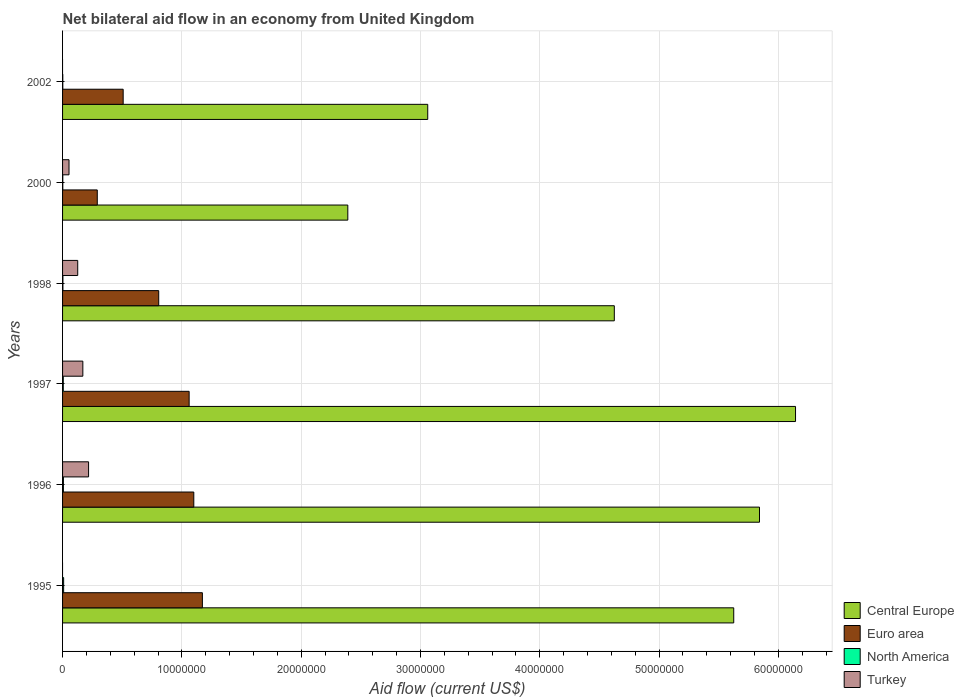How many groups of bars are there?
Your answer should be compact. 6. Are the number of bars per tick equal to the number of legend labels?
Offer a very short reply. No. Are the number of bars on each tick of the Y-axis equal?
Make the answer very short. No. How many bars are there on the 3rd tick from the top?
Offer a very short reply. 4. What is the label of the 1st group of bars from the top?
Offer a very short reply. 2002. What is the net bilateral aid flow in Euro area in 2002?
Give a very brief answer. 5.08e+06. Across all years, what is the minimum net bilateral aid flow in Euro area?
Provide a short and direct response. 2.91e+06. In which year was the net bilateral aid flow in Central Europe maximum?
Offer a terse response. 1997. What is the total net bilateral aid flow in North America in the graph?
Your answer should be compact. 2.90e+05. What is the difference between the net bilateral aid flow in Turkey in 1998 and that in 2000?
Your answer should be very brief. 7.30e+05. What is the difference between the net bilateral aid flow in Euro area in 2000 and the net bilateral aid flow in North America in 1995?
Give a very brief answer. 2.82e+06. What is the average net bilateral aid flow in North America per year?
Ensure brevity in your answer.  4.83e+04. In the year 1996, what is the difference between the net bilateral aid flow in Euro area and net bilateral aid flow in Turkey?
Your response must be concise. 8.82e+06. What is the ratio of the net bilateral aid flow in North America in 1995 to that in 1997?
Offer a terse response. 1.5. What is the difference between the highest and the second highest net bilateral aid flow in Central Europe?
Make the answer very short. 3.02e+06. What is the difference between the highest and the lowest net bilateral aid flow in Euro area?
Provide a short and direct response. 8.81e+06. Is the sum of the net bilateral aid flow in North America in 1997 and 2000 greater than the maximum net bilateral aid flow in Turkey across all years?
Provide a short and direct response. No. Is it the case that in every year, the sum of the net bilateral aid flow in Euro area and net bilateral aid flow in Central Europe is greater than the net bilateral aid flow in Turkey?
Offer a terse response. Yes. Where does the legend appear in the graph?
Provide a succinct answer. Bottom right. How many legend labels are there?
Your answer should be compact. 4. What is the title of the graph?
Provide a short and direct response. Net bilateral aid flow in an economy from United Kingdom. Does "St. Martin (French part)" appear as one of the legend labels in the graph?
Keep it short and to the point. No. What is the label or title of the X-axis?
Provide a short and direct response. Aid flow (current US$). What is the Aid flow (current US$) in Central Europe in 1995?
Your answer should be very brief. 5.63e+07. What is the Aid flow (current US$) in Euro area in 1995?
Make the answer very short. 1.17e+07. What is the Aid flow (current US$) in North America in 1995?
Give a very brief answer. 9.00e+04. What is the Aid flow (current US$) of Central Europe in 1996?
Offer a terse response. 5.84e+07. What is the Aid flow (current US$) in Euro area in 1996?
Offer a terse response. 1.10e+07. What is the Aid flow (current US$) in Turkey in 1996?
Provide a succinct answer. 2.18e+06. What is the Aid flow (current US$) in Central Europe in 1997?
Provide a short and direct response. 6.14e+07. What is the Aid flow (current US$) of Euro area in 1997?
Your response must be concise. 1.06e+07. What is the Aid flow (current US$) in North America in 1997?
Provide a succinct answer. 6.00e+04. What is the Aid flow (current US$) of Turkey in 1997?
Offer a very short reply. 1.70e+06. What is the Aid flow (current US$) in Central Europe in 1998?
Provide a succinct answer. 4.62e+07. What is the Aid flow (current US$) of Euro area in 1998?
Your answer should be very brief. 8.06e+06. What is the Aid flow (current US$) in North America in 1998?
Keep it short and to the point. 3.00e+04. What is the Aid flow (current US$) in Turkey in 1998?
Make the answer very short. 1.27e+06. What is the Aid flow (current US$) in Central Europe in 2000?
Make the answer very short. 2.39e+07. What is the Aid flow (current US$) in Euro area in 2000?
Offer a very short reply. 2.91e+06. What is the Aid flow (current US$) in Turkey in 2000?
Ensure brevity in your answer.  5.40e+05. What is the Aid flow (current US$) of Central Europe in 2002?
Your answer should be very brief. 3.06e+07. What is the Aid flow (current US$) of Euro area in 2002?
Your response must be concise. 5.08e+06. What is the Aid flow (current US$) in Turkey in 2002?
Your answer should be very brief. 0. Across all years, what is the maximum Aid flow (current US$) in Central Europe?
Give a very brief answer. 6.14e+07. Across all years, what is the maximum Aid flow (current US$) in Euro area?
Offer a terse response. 1.17e+07. Across all years, what is the maximum Aid flow (current US$) in Turkey?
Offer a terse response. 2.18e+06. Across all years, what is the minimum Aid flow (current US$) in Central Europe?
Keep it short and to the point. 2.39e+07. Across all years, what is the minimum Aid flow (current US$) in Euro area?
Provide a short and direct response. 2.91e+06. What is the total Aid flow (current US$) in Central Europe in the graph?
Keep it short and to the point. 2.77e+08. What is the total Aid flow (current US$) in Euro area in the graph?
Offer a terse response. 4.94e+07. What is the total Aid flow (current US$) in Turkey in the graph?
Give a very brief answer. 5.69e+06. What is the difference between the Aid flow (current US$) in Central Europe in 1995 and that in 1996?
Give a very brief answer. -2.16e+06. What is the difference between the Aid flow (current US$) of Euro area in 1995 and that in 1996?
Offer a terse response. 7.20e+05. What is the difference between the Aid flow (current US$) in Central Europe in 1995 and that in 1997?
Your answer should be very brief. -5.18e+06. What is the difference between the Aid flow (current US$) in Euro area in 1995 and that in 1997?
Make the answer very short. 1.11e+06. What is the difference between the Aid flow (current US$) of North America in 1995 and that in 1997?
Keep it short and to the point. 3.00e+04. What is the difference between the Aid flow (current US$) of Central Europe in 1995 and that in 1998?
Your answer should be very brief. 1.00e+07. What is the difference between the Aid flow (current US$) in Euro area in 1995 and that in 1998?
Ensure brevity in your answer.  3.66e+06. What is the difference between the Aid flow (current US$) of Central Europe in 1995 and that in 2000?
Your answer should be compact. 3.24e+07. What is the difference between the Aid flow (current US$) of Euro area in 1995 and that in 2000?
Offer a terse response. 8.81e+06. What is the difference between the Aid flow (current US$) of Central Europe in 1995 and that in 2002?
Your answer should be compact. 2.56e+07. What is the difference between the Aid flow (current US$) in Euro area in 1995 and that in 2002?
Provide a short and direct response. 6.64e+06. What is the difference between the Aid flow (current US$) of North America in 1995 and that in 2002?
Your response must be concise. 7.00e+04. What is the difference between the Aid flow (current US$) in Central Europe in 1996 and that in 1997?
Offer a terse response. -3.02e+06. What is the difference between the Aid flow (current US$) of Turkey in 1996 and that in 1997?
Ensure brevity in your answer.  4.80e+05. What is the difference between the Aid flow (current US$) in Central Europe in 1996 and that in 1998?
Provide a succinct answer. 1.22e+07. What is the difference between the Aid flow (current US$) in Euro area in 1996 and that in 1998?
Your response must be concise. 2.94e+06. What is the difference between the Aid flow (current US$) in North America in 1996 and that in 1998?
Give a very brief answer. 4.00e+04. What is the difference between the Aid flow (current US$) in Turkey in 1996 and that in 1998?
Keep it short and to the point. 9.10e+05. What is the difference between the Aid flow (current US$) in Central Europe in 1996 and that in 2000?
Give a very brief answer. 3.45e+07. What is the difference between the Aid flow (current US$) of Euro area in 1996 and that in 2000?
Keep it short and to the point. 8.09e+06. What is the difference between the Aid flow (current US$) of Turkey in 1996 and that in 2000?
Offer a terse response. 1.64e+06. What is the difference between the Aid flow (current US$) of Central Europe in 1996 and that in 2002?
Ensure brevity in your answer.  2.78e+07. What is the difference between the Aid flow (current US$) of Euro area in 1996 and that in 2002?
Make the answer very short. 5.92e+06. What is the difference between the Aid flow (current US$) of North America in 1996 and that in 2002?
Your response must be concise. 5.00e+04. What is the difference between the Aid flow (current US$) in Central Europe in 1997 and that in 1998?
Make the answer very short. 1.52e+07. What is the difference between the Aid flow (current US$) of Euro area in 1997 and that in 1998?
Make the answer very short. 2.55e+06. What is the difference between the Aid flow (current US$) in Central Europe in 1997 and that in 2000?
Make the answer very short. 3.75e+07. What is the difference between the Aid flow (current US$) of Euro area in 1997 and that in 2000?
Give a very brief answer. 7.70e+06. What is the difference between the Aid flow (current US$) of Turkey in 1997 and that in 2000?
Offer a very short reply. 1.16e+06. What is the difference between the Aid flow (current US$) of Central Europe in 1997 and that in 2002?
Keep it short and to the point. 3.08e+07. What is the difference between the Aid flow (current US$) of Euro area in 1997 and that in 2002?
Provide a short and direct response. 5.53e+06. What is the difference between the Aid flow (current US$) in North America in 1997 and that in 2002?
Provide a succinct answer. 4.00e+04. What is the difference between the Aid flow (current US$) in Central Europe in 1998 and that in 2000?
Keep it short and to the point. 2.23e+07. What is the difference between the Aid flow (current US$) in Euro area in 1998 and that in 2000?
Provide a short and direct response. 5.15e+06. What is the difference between the Aid flow (current US$) in Turkey in 1998 and that in 2000?
Provide a succinct answer. 7.30e+05. What is the difference between the Aid flow (current US$) of Central Europe in 1998 and that in 2002?
Make the answer very short. 1.56e+07. What is the difference between the Aid flow (current US$) of Euro area in 1998 and that in 2002?
Provide a succinct answer. 2.98e+06. What is the difference between the Aid flow (current US$) of Central Europe in 2000 and that in 2002?
Your answer should be compact. -6.70e+06. What is the difference between the Aid flow (current US$) of Euro area in 2000 and that in 2002?
Provide a succinct answer. -2.17e+06. What is the difference between the Aid flow (current US$) in Central Europe in 1995 and the Aid flow (current US$) in Euro area in 1996?
Offer a terse response. 4.53e+07. What is the difference between the Aid flow (current US$) in Central Europe in 1995 and the Aid flow (current US$) in North America in 1996?
Your response must be concise. 5.62e+07. What is the difference between the Aid flow (current US$) in Central Europe in 1995 and the Aid flow (current US$) in Turkey in 1996?
Give a very brief answer. 5.41e+07. What is the difference between the Aid flow (current US$) of Euro area in 1995 and the Aid flow (current US$) of North America in 1996?
Make the answer very short. 1.16e+07. What is the difference between the Aid flow (current US$) in Euro area in 1995 and the Aid flow (current US$) in Turkey in 1996?
Provide a short and direct response. 9.54e+06. What is the difference between the Aid flow (current US$) in North America in 1995 and the Aid flow (current US$) in Turkey in 1996?
Your answer should be very brief. -2.09e+06. What is the difference between the Aid flow (current US$) in Central Europe in 1995 and the Aid flow (current US$) in Euro area in 1997?
Keep it short and to the point. 4.56e+07. What is the difference between the Aid flow (current US$) in Central Europe in 1995 and the Aid flow (current US$) in North America in 1997?
Make the answer very short. 5.62e+07. What is the difference between the Aid flow (current US$) in Central Europe in 1995 and the Aid flow (current US$) in Turkey in 1997?
Provide a short and direct response. 5.46e+07. What is the difference between the Aid flow (current US$) in Euro area in 1995 and the Aid flow (current US$) in North America in 1997?
Your response must be concise. 1.17e+07. What is the difference between the Aid flow (current US$) of Euro area in 1995 and the Aid flow (current US$) of Turkey in 1997?
Keep it short and to the point. 1.00e+07. What is the difference between the Aid flow (current US$) of North America in 1995 and the Aid flow (current US$) of Turkey in 1997?
Ensure brevity in your answer.  -1.61e+06. What is the difference between the Aid flow (current US$) of Central Europe in 1995 and the Aid flow (current US$) of Euro area in 1998?
Make the answer very short. 4.82e+07. What is the difference between the Aid flow (current US$) in Central Europe in 1995 and the Aid flow (current US$) in North America in 1998?
Provide a short and direct response. 5.62e+07. What is the difference between the Aid flow (current US$) in Central Europe in 1995 and the Aid flow (current US$) in Turkey in 1998?
Give a very brief answer. 5.50e+07. What is the difference between the Aid flow (current US$) of Euro area in 1995 and the Aid flow (current US$) of North America in 1998?
Ensure brevity in your answer.  1.17e+07. What is the difference between the Aid flow (current US$) in Euro area in 1995 and the Aid flow (current US$) in Turkey in 1998?
Your response must be concise. 1.04e+07. What is the difference between the Aid flow (current US$) in North America in 1995 and the Aid flow (current US$) in Turkey in 1998?
Offer a very short reply. -1.18e+06. What is the difference between the Aid flow (current US$) in Central Europe in 1995 and the Aid flow (current US$) in Euro area in 2000?
Ensure brevity in your answer.  5.34e+07. What is the difference between the Aid flow (current US$) of Central Europe in 1995 and the Aid flow (current US$) of North America in 2000?
Give a very brief answer. 5.62e+07. What is the difference between the Aid flow (current US$) in Central Europe in 1995 and the Aid flow (current US$) in Turkey in 2000?
Your answer should be very brief. 5.57e+07. What is the difference between the Aid flow (current US$) in Euro area in 1995 and the Aid flow (current US$) in North America in 2000?
Your answer should be very brief. 1.17e+07. What is the difference between the Aid flow (current US$) in Euro area in 1995 and the Aid flow (current US$) in Turkey in 2000?
Make the answer very short. 1.12e+07. What is the difference between the Aid flow (current US$) in North America in 1995 and the Aid flow (current US$) in Turkey in 2000?
Offer a very short reply. -4.50e+05. What is the difference between the Aid flow (current US$) in Central Europe in 1995 and the Aid flow (current US$) in Euro area in 2002?
Offer a very short reply. 5.12e+07. What is the difference between the Aid flow (current US$) in Central Europe in 1995 and the Aid flow (current US$) in North America in 2002?
Offer a very short reply. 5.62e+07. What is the difference between the Aid flow (current US$) in Euro area in 1995 and the Aid flow (current US$) in North America in 2002?
Offer a terse response. 1.17e+07. What is the difference between the Aid flow (current US$) in Central Europe in 1996 and the Aid flow (current US$) in Euro area in 1997?
Your answer should be compact. 4.78e+07. What is the difference between the Aid flow (current US$) of Central Europe in 1996 and the Aid flow (current US$) of North America in 1997?
Offer a terse response. 5.84e+07. What is the difference between the Aid flow (current US$) in Central Europe in 1996 and the Aid flow (current US$) in Turkey in 1997?
Your answer should be very brief. 5.67e+07. What is the difference between the Aid flow (current US$) in Euro area in 1996 and the Aid flow (current US$) in North America in 1997?
Give a very brief answer. 1.09e+07. What is the difference between the Aid flow (current US$) of Euro area in 1996 and the Aid flow (current US$) of Turkey in 1997?
Ensure brevity in your answer.  9.30e+06. What is the difference between the Aid flow (current US$) of North America in 1996 and the Aid flow (current US$) of Turkey in 1997?
Your answer should be compact. -1.63e+06. What is the difference between the Aid flow (current US$) of Central Europe in 1996 and the Aid flow (current US$) of Euro area in 1998?
Make the answer very short. 5.04e+07. What is the difference between the Aid flow (current US$) of Central Europe in 1996 and the Aid flow (current US$) of North America in 1998?
Make the answer very short. 5.84e+07. What is the difference between the Aid flow (current US$) in Central Europe in 1996 and the Aid flow (current US$) in Turkey in 1998?
Give a very brief answer. 5.72e+07. What is the difference between the Aid flow (current US$) of Euro area in 1996 and the Aid flow (current US$) of North America in 1998?
Your response must be concise. 1.10e+07. What is the difference between the Aid flow (current US$) in Euro area in 1996 and the Aid flow (current US$) in Turkey in 1998?
Give a very brief answer. 9.73e+06. What is the difference between the Aid flow (current US$) in North America in 1996 and the Aid flow (current US$) in Turkey in 1998?
Make the answer very short. -1.20e+06. What is the difference between the Aid flow (current US$) in Central Europe in 1996 and the Aid flow (current US$) in Euro area in 2000?
Ensure brevity in your answer.  5.55e+07. What is the difference between the Aid flow (current US$) in Central Europe in 1996 and the Aid flow (current US$) in North America in 2000?
Provide a short and direct response. 5.84e+07. What is the difference between the Aid flow (current US$) in Central Europe in 1996 and the Aid flow (current US$) in Turkey in 2000?
Your answer should be very brief. 5.79e+07. What is the difference between the Aid flow (current US$) in Euro area in 1996 and the Aid flow (current US$) in North America in 2000?
Your response must be concise. 1.10e+07. What is the difference between the Aid flow (current US$) in Euro area in 1996 and the Aid flow (current US$) in Turkey in 2000?
Give a very brief answer. 1.05e+07. What is the difference between the Aid flow (current US$) of North America in 1996 and the Aid flow (current US$) of Turkey in 2000?
Offer a very short reply. -4.70e+05. What is the difference between the Aid flow (current US$) in Central Europe in 1996 and the Aid flow (current US$) in Euro area in 2002?
Provide a succinct answer. 5.33e+07. What is the difference between the Aid flow (current US$) in Central Europe in 1996 and the Aid flow (current US$) in North America in 2002?
Your response must be concise. 5.84e+07. What is the difference between the Aid flow (current US$) of Euro area in 1996 and the Aid flow (current US$) of North America in 2002?
Make the answer very short. 1.10e+07. What is the difference between the Aid flow (current US$) of Central Europe in 1997 and the Aid flow (current US$) of Euro area in 1998?
Ensure brevity in your answer.  5.34e+07. What is the difference between the Aid flow (current US$) of Central Europe in 1997 and the Aid flow (current US$) of North America in 1998?
Make the answer very short. 6.14e+07. What is the difference between the Aid flow (current US$) in Central Europe in 1997 and the Aid flow (current US$) in Turkey in 1998?
Provide a short and direct response. 6.02e+07. What is the difference between the Aid flow (current US$) in Euro area in 1997 and the Aid flow (current US$) in North America in 1998?
Keep it short and to the point. 1.06e+07. What is the difference between the Aid flow (current US$) of Euro area in 1997 and the Aid flow (current US$) of Turkey in 1998?
Your answer should be compact. 9.34e+06. What is the difference between the Aid flow (current US$) of North America in 1997 and the Aid flow (current US$) of Turkey in 1998?
Make the answer very short. -1.21e+06. What is the difference between the Aid flow (current US$) of Central Europe in 1997 and the Aid flow (current US$) of Euro area in 2000?
Your answer should be compact. 5.85e+07. What is the difference between the Aid flow (current US$) in Central Europe in 1997 and the Aid flow (current US$) in North America in 2000?
Provide a short and direct response. 6.14e+07. What is the difference between the Aid flow (current US$) of Central Europe in 1997 and the Aid flow (current US$) of Turkey in 2000?
Provide a succinct answer. 6.09e+07. What is the difference between the Aid flow (current US$) of Euro area in 1997 and the Aid flow (current US$) of North America in 2000?
Provide a short and direct response. 1.06e+07. What is the difference between the Aid flow (current US$) in Euro area in 1997 and the Aid flow (current US$) in Turkey in 2000?
Your answer should be very brief. 1.01e+07. What is the difference between the Aid flow (current US$) in North America in 1997 and the Aid flow (current US$) in Turkey in 2000?
Your answer should be very brief. -4.80e+05. What is the difference between the Aid flow (current US$) of Central Europe in 1997 and the Aid flow (current US$) of Euro area in 2002?
Your answer should be compact. 5.64e+07. What is the difference between the Aid flow (current US$) of Central Europe in 1997 and the Aid flow (current US$) of North America in 2002?
Keep it short and to the point. 6.14e+07. What is the difference between the Aid flow (current US$) of Euro area in 1997 and the Aid flow (current US$) of North America in 2002?
Your answer should be very brief. 1.06e+07. What is the difference between the Aid flow (current US$) of Central Europe in 1998 and the Aid flow (current US$) of Euro area in 2000?
Make the answer very short. 4.33e+07. What is the difference between the Aid flow (current US$) of Central Europe in 1998 and the Aid flow (current US$) of North America in 2000?
Provide a succinct answer. 4.62e+07. What is the difference between the Aid flow (current US$) in Central Europe in 1998 and the Aid flow (current US$) in Turkey in 2000?
Offer a very short reply. 4.57e+07. What is the difference between the Aid flow (current US$) in Euro area in 1998 and the Aid flow (current US$) in North America in 2000?
Your answer should be compact. 8.04e+06. What is the difference between the Aid flow (current US$) of Euro area in 1998 and the Aid flow (current US$) of Turkey in 2000?
Provide a succinct answer. 7.52e+06. What is the difference between the Aid flow (current US$) of North America in 1998 and the Aid flow (current US$) of Turkey in 2000?
Provide a succinct answer. -5.10e+05. What is the difference between the Aid flow (current US$) in Central Europe in 1998 and the Aid flow (current US$) in Euro area in 2002?
Offer a very short reply. 4.12e+07. What is the difference between the Aid flow (current US$) of Central Europe in 1998 and the Aid flow (current US$) of North America in 2002?
Make the answer very short. 4.62e+07. What is the difference between the Aid flow (current US$) of Euro area in 1998 and the Aid flow (current US$) of North America in 2002?
Offer a very short reply. 8.04e+06. What is the difference between the Aid flow (current US$) of Central Europe in 2000 and the Aid flow (current US$) of Euro area in 2002?
Your answer should be very brief. 1.88e+07. What is the difference between the Aid flow (current US$) of Central Europe in 2000 and the Aid flow (current US$) of North America in 2002?
Provide a short and direct response. 2.39e+07. What is the difference between the Aid flow (current US$) of Euro area in 2000 and the Aid flow (current US$) of North America in 2002?
Your answer should be very brief. 2.89e+06. What is the average Aid flow (current US$) in Central Europe per year?
Provide a short and direct response. 4.61e+07. What is the average Aid flow (current US$) of Euro area per year?
Your response must be concise. 8.23e+06. What is the average Aid flow (current US$) in North America per year?
Offer a terse response. 4.83e+04. What is the average Aid flow (current US$) of Turkey per year?
Ensure brevity in your answer.  9.48e+05. In the year 1995, what is the difference between the Aid flow (current US$) in Central Europe and Aid flow (current US$) in Euro area?
Your answer should be compact. 4.45e+07. In the year 1995, what is the difference between the Aid flow (current US$) of Central Europe and Aid flow (current US$) of North America?
Offer a very short reply. 5.62e+07. In the year 1995, what is the difference between the Aid flow (current US$) of Euro area and Aid flow (current US$) of North America?
Offer a terse response. 1.16e+07. In the year 1996, what is the difference between the Aid flow (current US$) in Central Europe and Aid flow (current US$) in Euro area?
Provide a succinct answer. 4.74e+07. In the year 1996, what is the difference between the Aid flow (current US$) in Central Europe and Aid flow (current US$) in North America?
Your answer should be very brief. 5.84e+07. In the year 1996, what is the difference between the Aid flow (current US$) in Central Europe and Aid flow (current US$) in Turkey?
Keep it short and to the point. 5.62e+07. In the year 1996, what is the difference between the Aid flow (current US$) of Euro area and Aid flow (current US$) of North America?
Make the answer very short. 1.09e+07. In the year 1996, what is the difference between the Aid flow (current US$) in Euro area and Aid flow (current US$) in Turkey?
Ensure brevity in your answer.  8.82e+06. In the year 1996, what is the difference between the Aid flow (current US$) in North America and Aid flow (current US$) in Turkey?
Ensure brevity in your answer.  -2.11e+06. In the year 1997, what is the difference between the Aid flow (current US$) of Central Europe and Aid flow (current US$) of Euro area?
Keep it short and to the point. 5.08e+07. In the year 1997, what is the difference between the Aid flow (current US$) in Central Europe and Aid flow (current US$) in North America?
Your response must be concise. 6.14e+07. In the year 1997, what is the difference between the Aid flow (current US$) in Central Europe and Aid flow (current US$) in Turkey?
Ensure brevity in your answer.  5.97e+07. In the year 1997, what is the difference between the Aid flow (current US$) of Euro area and Aid flow (current US$) of North America?
Offer a terse response. 1.06e+07. In the year 1997, what is the difference between the Aid flow (current US$) in Euro area and Aid flow (current US$) in Turkey?
Offer a terse response. 8.91e+06. In the year 1997, what is the difference between the Aid flow (current US$) in North America and Aid flow (current US$) in Turkey?
Give a very brief answer. -1.64e+06. In the year 1998, what is the difference between the Aid flow (current US$) of Central Europe and Aid flow (current US$) of Euro area?
Your response must be concise. 3.82e+07. In the year 1998, what is the difference between the Aid flow (current US$) of Central Europe and Aid flow (current US$) of North America?
Give a very brief answer. 4.62e+07. In the year 1998, what is the difference between the Aid flow (current US$) in Central Europe and Aid flow (current US$) in Turkey?
Your answer should be compact. 4.50e+07. In the year 1998, what is the difference between the Aid flow (current US$) in Euro area and Aid flow (current US$) in North America?
Offer a terse response. 8.03e+06. In the year 1998, what is the difference between the Aid flow (current US$) in Euro area and Aid flow (current US$) in Turkey?
Your answer should be very brief. 6.79e+06. In the year 1998, what is the difference between the Aid flow (current US$) in North America and Aid flow (current US$) in Turkey?
Your answer should be compact. -1.24e+06. In the year 2000, what is the difference between the Aid flow (current US$) of Central Europe and Aid flow (current US$) of Euro area?
Your answer should be very brief. 2.10e+07. In the year 2000, what is the difference between the Aid flow (current US$) in Central Europe and Aid flow (current US$) in North America?
Provide a succinct answer. 2.39e+07. In the year 2000, what is the difference between the Aid flow (current US$) in Central Europe and Aid flow (current US$) in Turkey?
Keep it short and to the point. 2.34e+07. In the year 2000, what is the difference between the Aid flow (current US$) of Euro area and Aid flow (current US$) of North America?
Offer a terse response. 2.89e+06. In the year 2000, what is the difference between the Aid flow (current US$) in Euro area and Aid flow (current US$) in Turkey?
Offer a very short reply. 2.37e+06. In the year 2000, what is the difference between the Aid flow (current US$) in North America and Aid flow (current US$) in Turkey?
Offer a terse response. -5.20e+05. In the year 2002, what is the difference between the Aid flow (current US$) of Central Europe and Aid flow (current US$) of Euro area?
Keep it short and to the point. 2.55e+07. In the year 2002, what is the difference between the Aid flow (current US$) of Central Europe and Aid flow (current US$) of North America?
Your response must be concise. 3.06e+07. In the year 2002, what is the difference between the Aid flow (current US$) in Euro area and Aid flow (current US$) in North America?
Provide a short and direct response. 5.06e+06. What is the ratio of the Aid flow (current US$) in Euro area in 1995 to that in 1996?
Offer a terse response. 1.07. What is the ratio of the Aid flow (current US$) of Central Europe in 1995 to that in 1997?
Your answer should be compact. 0.92. What is the ratio of the Aid flow (current US$) in Euro area in 1995 to that in 1997?
Keep it short and to the point. 1.1. What is the ratio of the Aid flow (current US$) of North America in 1995 to that in 1997?
Offer a very short reply. 1.5. What is the ratio of the Aid flow (current US$) in Central Europe in 1995 to that in 1998?
Your answer should be compact. 1.22. What is the ratio of the Aid flow (current US$) of Euro area in 1995 to that in 1998?
Keep it short and to the point. 1.45. What is the ratio of the Aid flow (current US$) in North America in 1995 to that in 1998?
Your answer should be compact. 3. What is the ratio of the Aid flow (current US$) of Central Europe in 1995 to that in 2000?
Your answer should be compact. 2.35. What is the ratio of the Aid flow (current US$) of Euro area in 1995 to that in 2000?
Keep it short and to the point. 4.03. What is the ratio of the Aid flow (current US$) in North America in 1995 to that in 2000?
Your answer should be very brief. 4.5. What is the ratio of the Aid flow (current US$) of Central Europe in 1995 to that in 2002?
Give a very brief answer. 1.84. What is the ratio of the Aid flow (current US$) in Euro area in 1995 to that in 2002?
Ensure brevity in your answer.  2.31. What is the ratio of the Aid flow (current US$) in North America in 1995 to that in 2002?
Make the answer very short. 4.5. What is the ratio of the Aid flow (current US$) in Central Europe in 1996 to that in 1997?
Your answer should be compact. 0.95. What is the ratio of the Aid flow (current US$) of Euro area in 1996 to that in 1997?
Your response must be concise. 1.04. What is the ratio of the Aid flow (current US$) in Turkey in 1996 to that in 1997?
Keep it short and to the point. 1.28. What is the ratio of the Aid flow (current US$) of Central Europe in 1996 to that in 1998?
Keep it short and to the point. 1.26. What is the ratio of the Aid flow (current US$) of Euro area in 1996 to that in 1998?
Your answer should be compact. 1.36. What is the ratio of the Aid flow (current US$) in North America in 1996 to that in 1998?
Your answer should be very brief. 2.33. What is the ratio of the Aid flow (current US$) in Turkey in 1996 to that in 1998?
Offer a terse response. 1.72. What is the ratio of the Aid flow (current US$) of Central Europe in 1996 to that in 2000?
Ensure brevity in your answer.  2.44. What is the ratio of the Aid flow (current US$) of Euro area in 1996 to that in 2000?
Provide a short and direct response. 3.78. What is the ratio of the Aid flow (current US$) of North America in 1996 to that in 2000?
Your answer should be very brief. 3.5. What is the ratio of the Aid flow (current US$) in Turkey in 1996 to that in 2000?
Give a very brief answer. 4.04. What is the ratio of the Aid flow (current US$) in Central Europe in 1996 to that in 2002?
Your answer should be very brief. 1.91. What is the ratio of the Aid flow (current US$) in Euro area in 1996 to that in 2002?
Your answer should be compact. 2.17. What is the ratio of the Aid flow (current US$) in North America in 1996 to that in 2002?
Your answer should be compact. 3.5. What is the ratio of the Aid flow (current US$) in Central Europe in 1997 to that in 1998?
Your answer should be compact. 1.33. What is the ratio of the Aid flow (current US$) in Euro area in 1997 to that in 1998?
Keep it short and to the point. 1.32. What is the ratio of the Aid flow (current US$) of North America in 1997 to that in 1998?
Your response must be concise. 2. What is the ratio of the Aid flow (current US$) of Turkey in 1997 to that in 1998?
Provide a succinct answer. 1.34. What is the ratio of the Aid flow (current US$) of Central Europe in 1997 to that in 2000?
Keep it short and to the point. 2.57. What is the ratio of the Aid flow (current US$) in Euro area in 1997 to that in 2000?
Ensure brevity in your answer.  3.65. What is the ratio of the Aid flow (current US$) of North America in 1997 to that in 2000?
Provide a short and direct response. 3. What is the ratio of the Aid flow (current US$) of Turkey in 1997 to that in 2000?
Give a very brief answer. 3.15. What is the ratio of the Aid flow (current US$) of Central Europe in 1997 to that in 2002?
Offer a terse response. 2.01. What is the ratio of the Aid flow (current US$) in Euro area in 1997 to that in 2002?
Your answer should be compact. 2.09. What is the ratio of the Aid flow (current US$) in North America in 1997 to that in 2002?
Offer a very short reply. 3. What is the ratio of the Aid flow (current US$) in Central Europe in 1998 to that in 2000?
Your answer should be compact. 1.93. What is the ratio of the Aid flow (current US$) of Euro area in 1998 to that in 2000?
Make the answer very short. 2.77. What is the ratio of the Aid flow (current US$) of Turkey in 1998 to that in 2000?
Ensure brevity in your answer.  2.35. What is the ratio of the Aid flow (current US$) in Central Europe in 1998 to that in 2002?
Your answer should be very brief. 1.51. What is the ratio of the Aid flow (current US$) of Euro area in 1998 to that in 2002?
Give a very brief answer. 1.59. What is the ratio of the Aid flow (current US$) of Central Europe in 2000 to that in 2002?
Provide a short and direct response. 0.78. What is the ratio of the Aid flow (current US$) of Euro area in 2000 to that in 2002?
Your answer should be compact. 0.57. What is the difference between the highest and the second highest Aid flow (current US$) in Central Europe?
Keep it short and to the point. 3.02e+06. What is the difference between the highest and the second highest Aid flow (current US$) in Euro area?
Keep it short and to the point. 7.20e+05. What is the difference between the highest and the second highest Aid flow (current US$) in Turkey?
Offer a very short reply. 4.80e+05. What is the difference between the highest and the lowest Aid flow (current US$) of Central Europe?
Your answer should be compact. 3.75e+07. What is the difference between the highest and the lowest Aid flow (current US$) of Euro area?
Provide a short and direct response. 8.81e+06. What is the difference between the highest and the lowest Aid flow (current US$) in North America?
Keep it short and to the point. 7.00e+04. What is the difference between the highest and the lowest Aid flow (current US$) in Turkey?
Provide a succinct answer. 2.18e+06. 